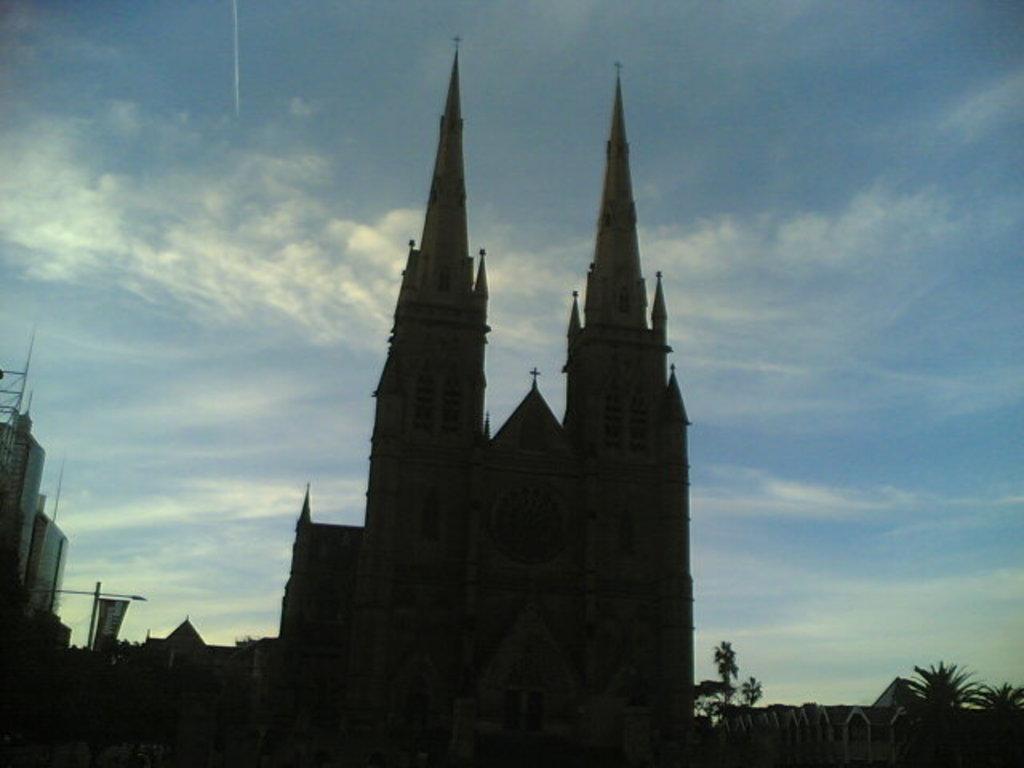Could you give a brief overview of what you see in this image? In this image there is a cathedral in the center. In the background there are buildings and trees. At the top there is the sky. 